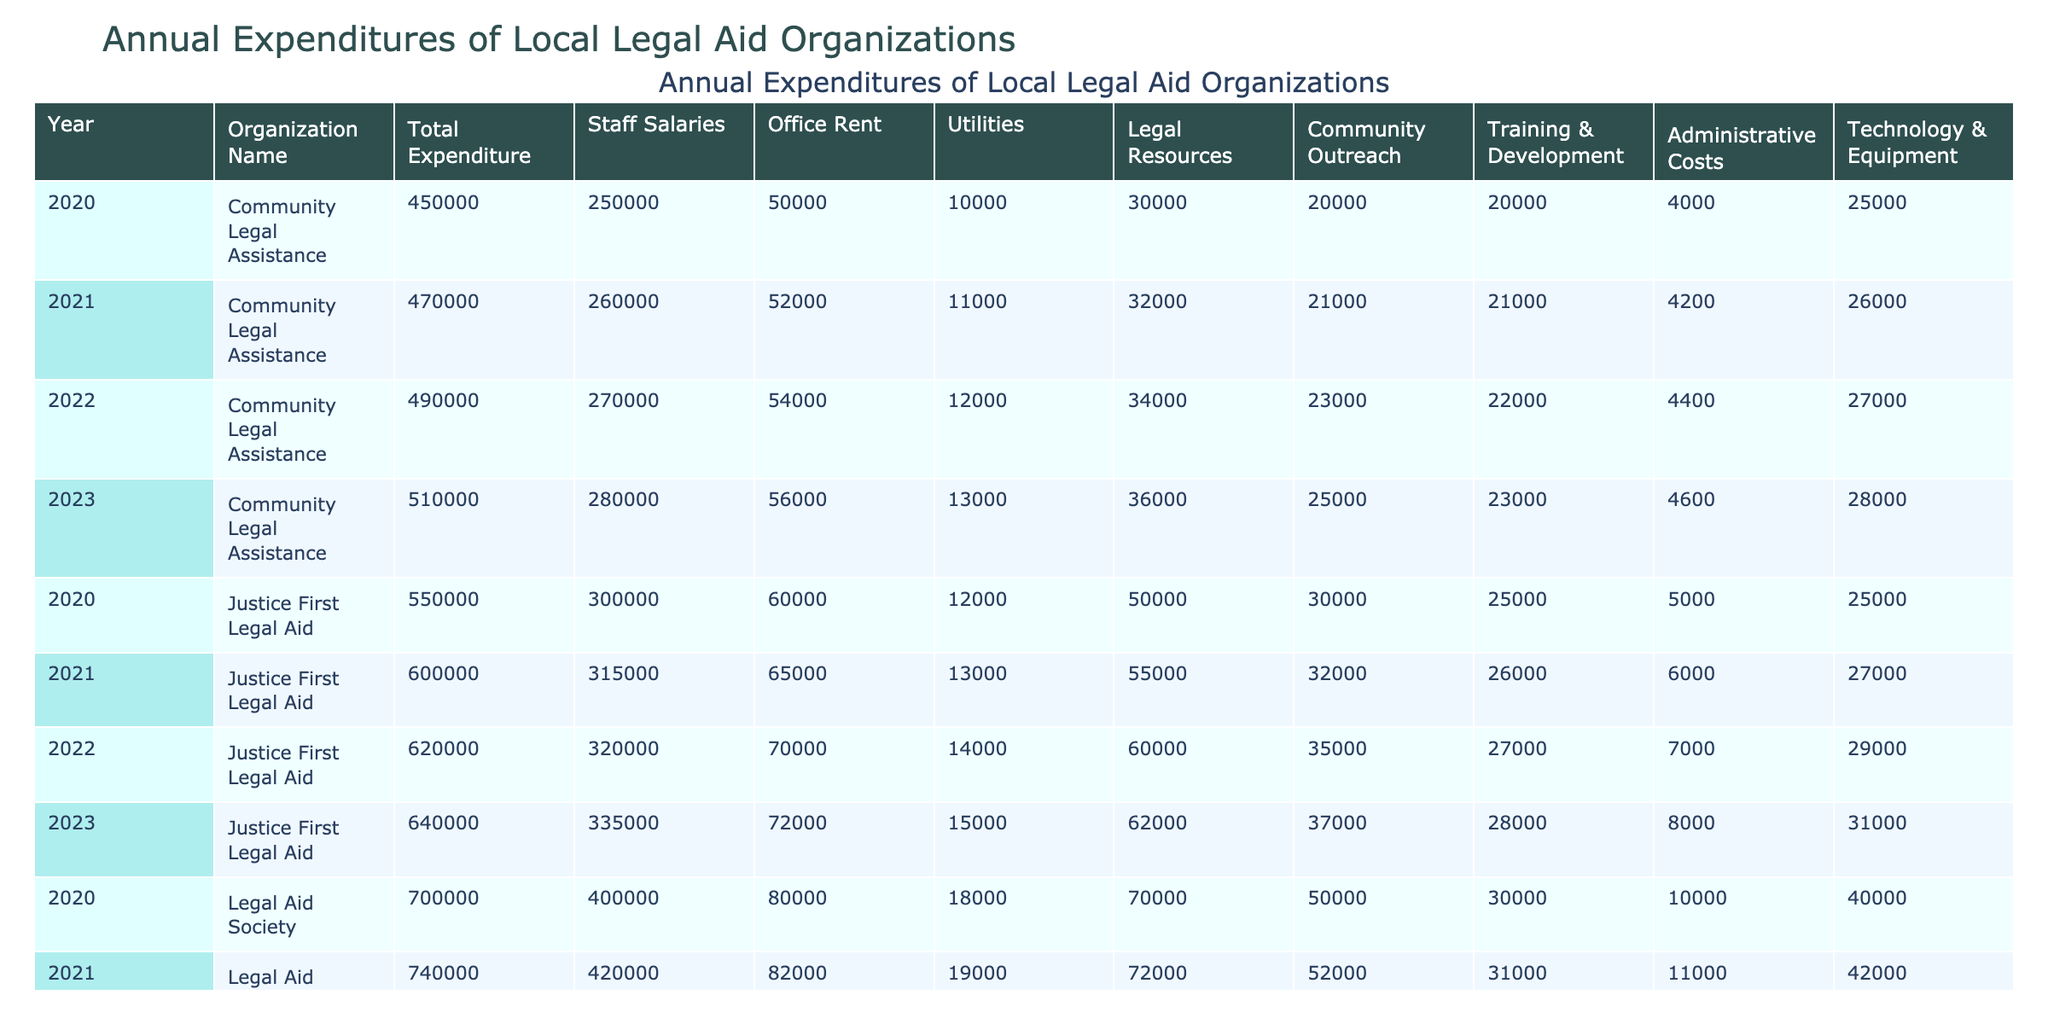What was the total expenditure of the Justice First Legal Aid in 2022? From the table, we observe the row for Justice First Legal Aid in 2022, which shows the total expenditure as 620000.
Answer: 620000 Which organization had the highest staff salaries in 2023? Reviewing the 2023 data, Legal Aid Society had staff salaries of 440000, which is higher than the other two organizations (335000 for Justice First Legal Aid and 280000 for Community Legal Assistance).
Answer: Legal Aid Society What was the average expenditure on legal resources for all organizations in 2021? Adding up the expenditures on legal resources for all organizations in 2021 yields 55000 (Justice First Legal Aid) + 32000 (Community Legal Assistance) + 72000 (Legal Aid Society) = 159000. Dividing this sum by the number of organizations (3) gives an average of 159000/3 = 53000.
Answer: 53000 Did the total expenditure for Community Legal Assistance increase every year from 2020 to 2023? By reviewing the total expenditures of Community Legal Assistance for each year, we see that it increased from 450000 in 2020 to 510000 in 2023, showing consistent growth through the years.
Answer: Yes What was the percentage increase in total expenditure for the Legal Aid Society from 2020 to 2023? The total expenditure increased from 700000 in 2020 to 780000 in 2023. The increase is 780000 - 700000 = 80000. To find the percentage, we calculate (80000/700000) * 100 = 11.43%.
Answer: 11.43% Which organization spent the least on administrative costs in 2022? Looking at the administrative costs in 2022, Justice First Legal Aid spent 27000, Community Legal Assistance spent 22000, and Legal Aid Society spent 32000. The least expenditure is 22000 by Community Legal Assistance.
Answer: Community Legal Assistance What was the total expenditure for all organizations combined in 2021? Summing the total expenditures from the table for 2021 gives 600000 (Justice First Legal Aid) + 470000 (Community Legal Assistance) + 740000 (Legal Aid Society) = 1810000.
Answer: 1810000 How much did the office rent increase for Justice First Legal Aid from 2020 to 2023? The office rent for Justice First Legal Aid increased from 60000 in 2020 to 72000 in 2023. Therefore, the increase is 72000 - 60000 = 12000.
Answer: 12000 Which year saw the highest total expenditure for Community Legal Assistance? By examining the total expenditures for Community Legal Assistance from 2020 through 2023, we see that the amount increased each year, reaching its highest at 510000 in 2023.
Answer: 2023 Were the utilities expenses for the Legal Aid Society lower than those of Justice First Legal Aid in 2021? The utilities expense for Legal Aid Society in 2021 was 19000, while Justice First Legal Aid's was 13000. Thus, the utilities expenses for the Legal Aid Society were not lower.
Answer: No 